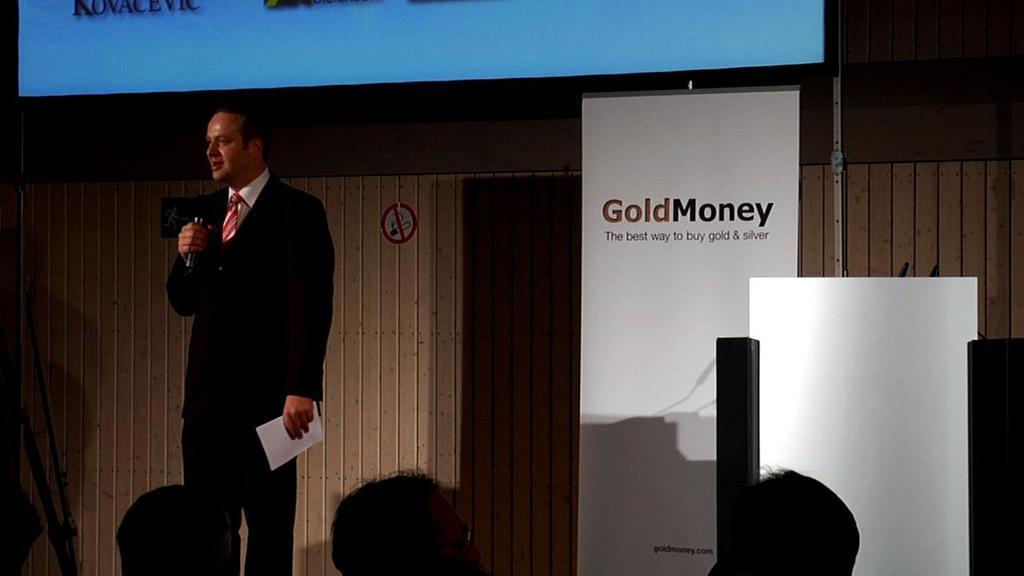Please provide a concise description of this image. This picture seems to be clicked inside the hall and we can see the group of people and there is a person wearing suit, holding some objects and standing. In the background we can see the text, some pictures and we can see some other objects in the background. 